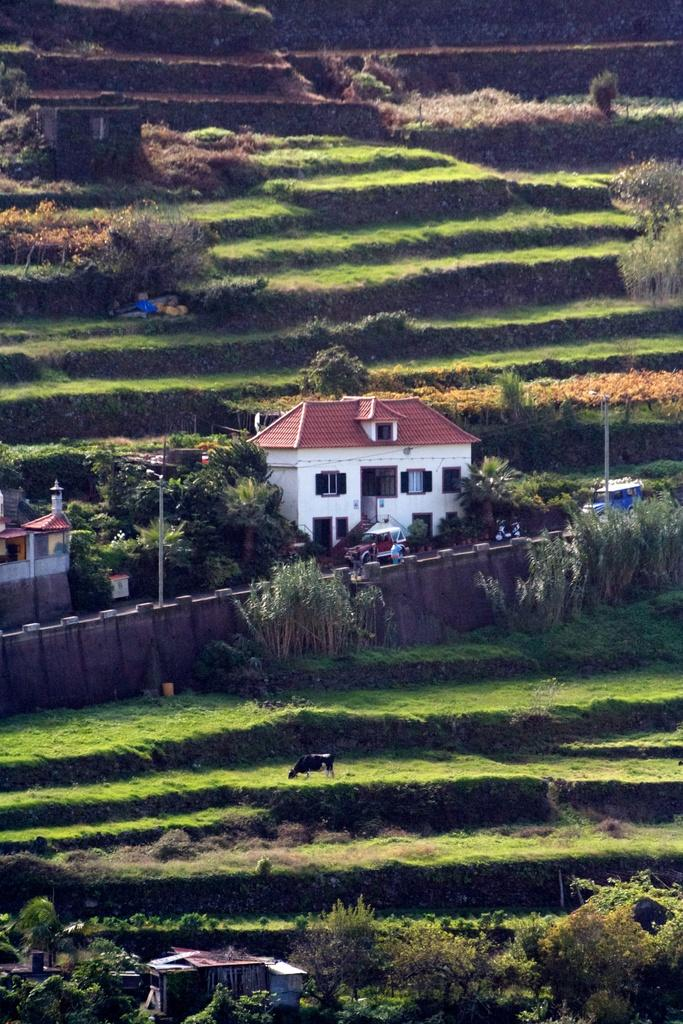What type of structures can be seen in the image? There are houses in the image. What other objects can be seen in the image? There are poles and a fence in the image. Are there any living creatures in the image? Yes, there is an animal in the image. What type of natural elements can be seen in the image? There are trees and fields in the image. Can you describe the steam coming from the chimney of the house in the image? There is no chimney or steam visible in the image. How does the kitty interact with the rainstorm in the image? There is no kitty or rainstorm present in the image. 